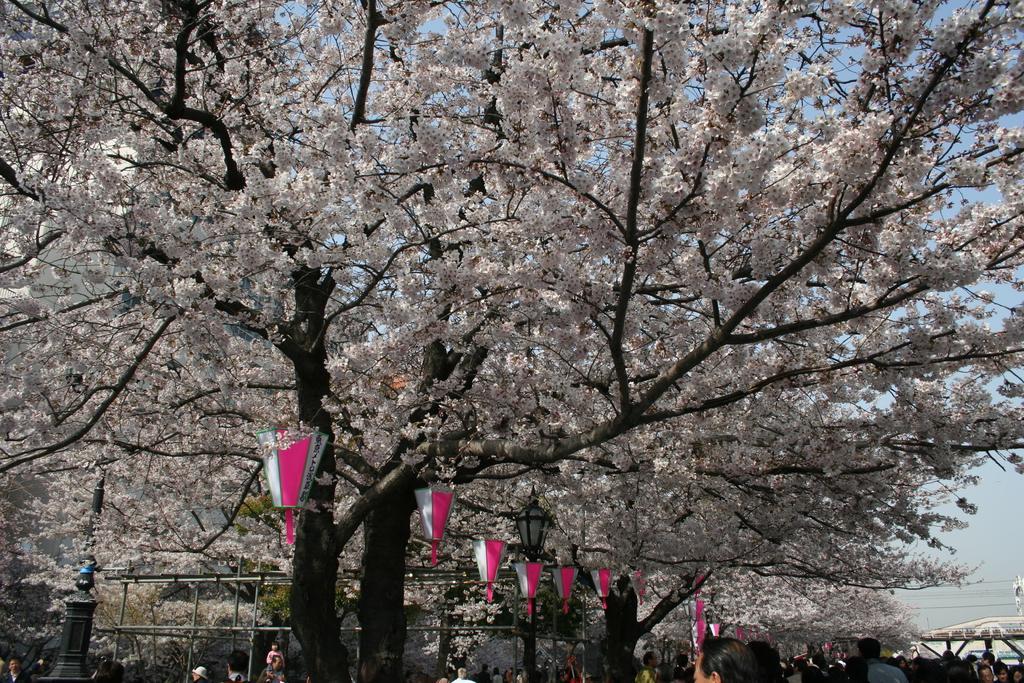In one or two sentences, can you explain what this image depicts? In this image, we can see a few trees. We can see some people. There are some poles. We can see the sky and some wires. 